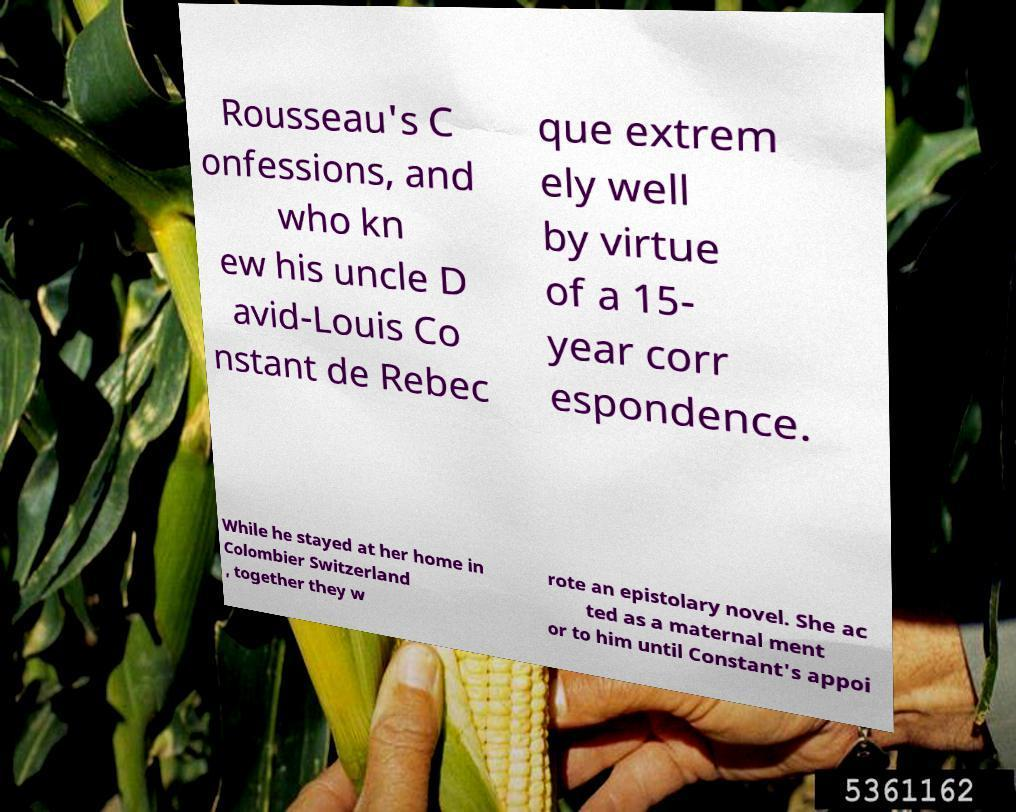What messages or text are displayed in this image? I need them in a readable, typed format. Rousseau's C onfessions, and who kn ew his uncle D avid-Louis Co nstant de Rebec que extrem ely well by virtue of a 15- year corr espondence. While he stayed at her home in Colombier Switzerland , together they w rote an epistolary novel. She ac ted as a maternal ment or to him until Constant's appoi 